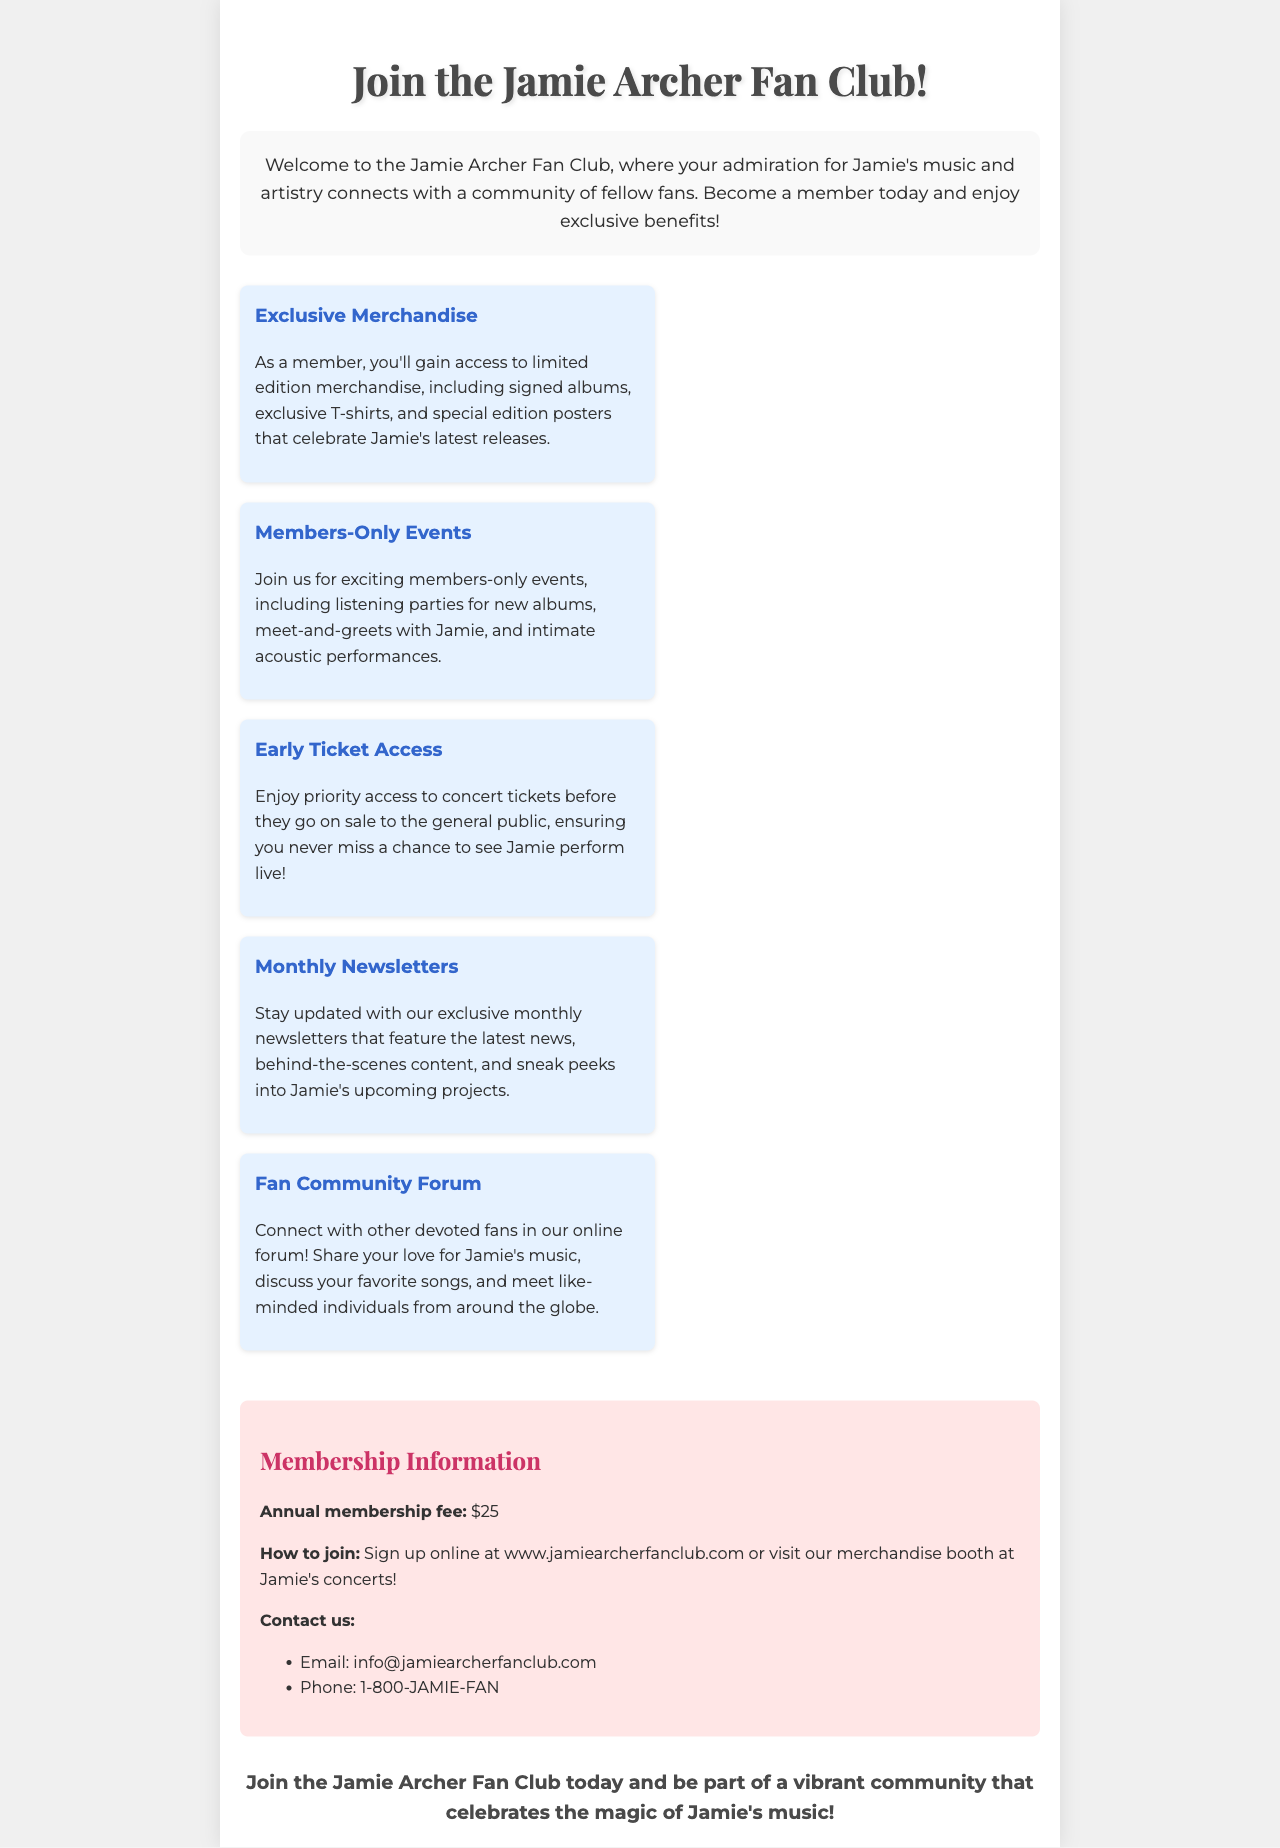What is the annual membership fee? The annual membership fee is stated in the membership information section of the brochure.
Answer: $25 What exclusive benefit includes early access to concert tickets? The benefit that includes early access to concert tickets is mentioned in the benefits section.
Answer: Early Ticket Access What type of events are held exclusively for members? The type of events held exclusively for members is referred to in the benefits section of the brochure.
Answer: Members-Only Events What is the website to sign up for membership? The website to sign up for membership is provided in the membership information section of the brochure.
Answer: www.jamiearcherfanclub.com How can you contact the fan club by phone? The contact information provided in the brochure includes a phone number specifically for reaching the fan club.
Answer: 1-800-JAMIE-FAN What kind of newsletters are sent to members? The type of newsletters sent to members is specified in the benefits section as part of the membership experience.
Answer: Monthly Newsletters Where can fans join the forum? The location of the fan community forum is detailed in the benefits section.
Answer: Online forum What kind of merchandise will members have access to? The type of access members have regarding merchandise is identified in the benefits section.
Answer: Exclusive Merchandise 